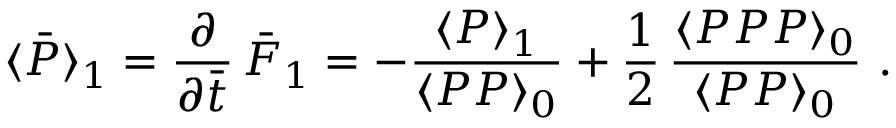<formula> <loc_0><loc_0><loc_500><loc_500>\langle \bar { P } \rangle _ { 1 } = { \frac { \partial } { \partial \bar { t } } } \, \bar { F } _ { 1 } = - { \frac { \langle P \rangle _ { 1 } } { \langle P P \rangle _ { 0 } } } + { \frac { 1 } { 2 } } \, { \frac { \langle P P P \rangle _ { 0 } } { \langle P P \rangle _ { 0 } } } \ .</formula> 